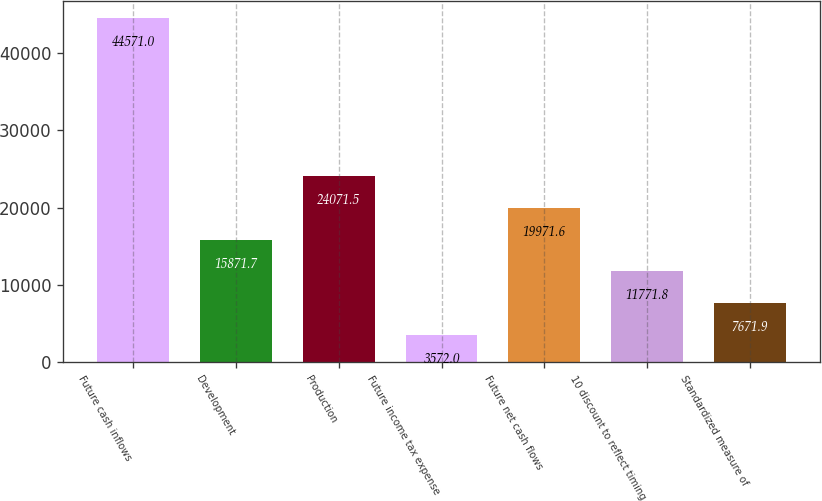Convert chart. <chart><loc_0><loc_0><loc_500><loc_500><bar_chart><fcel>Future cash inflows<fcel>Development<fcel>Production<fcel>Future income tax expense<fcel>Future net cash flows<fcel>10 discount to reflect timing<fcel>Standardized measure of<nl><fcel>44571<fcel>15871.7<fcel>24071.5<fcel>3572<fcel>19971.6<fcel>11771.8<fcel>7671.9<nl></chart> 